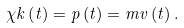<formula> <loc_0><loc_0><loc_500><loc_500>\chi k \left ( t \right ) = p \left ( t \right ) = m v \left ( t \right ) .</formula> 